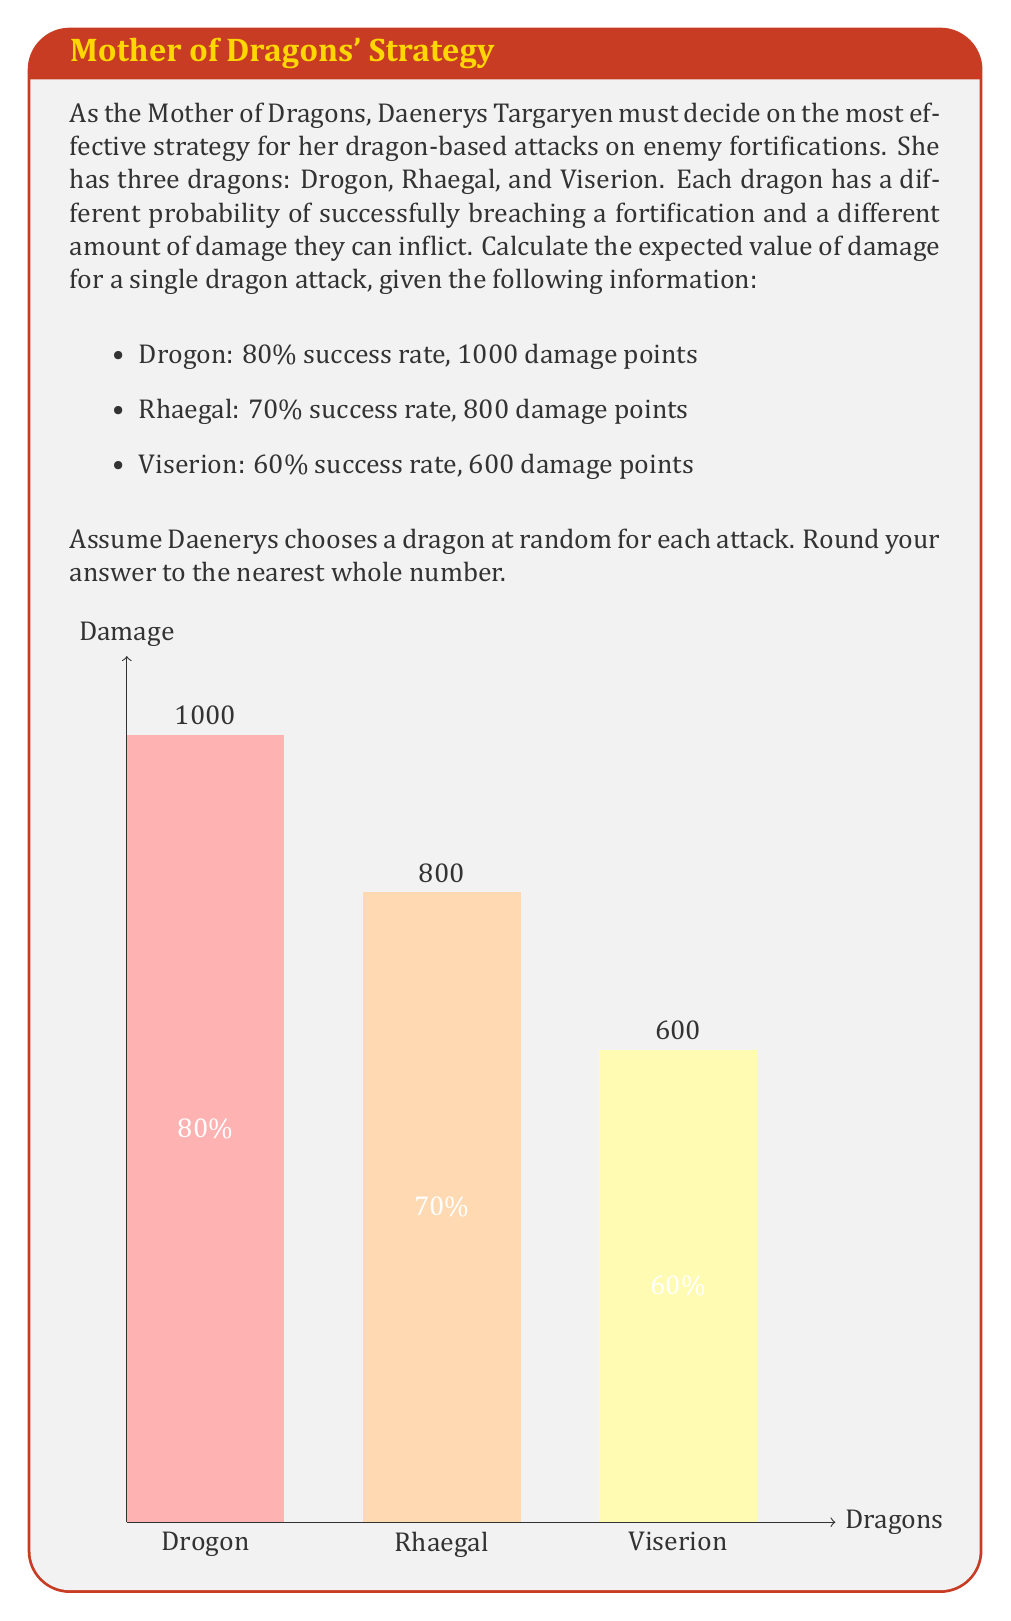Help me with this question. Let's approach this step-by-step:

1) First, we need to calculate the expected value of damage for each dragon:

   For Drogon: 
   $E(\text{Drogon}) = 0.80 \times 1000 + 0.20 \times 0 = 800$

   For Rhaegal:
   $E(\text{Rhaegal}) = 0.70 \times 800 + 0.30 \times 0 = 560$

   For Viserion:
   $E(\text{Viserion}) = 0.60 \times 600 + 0.40 \times 0 = 360$

2) Now, since Daenerys chooses a dragon at random, each dragon has an equal probability (1/3) of being chosen for an attack.

3) We can calculate the overall expected value by summing the products of each dragon's expected value and its probability of being chosen:

   $E(\text{attack}) = \frac{1}{3}E(\text{Drogon}) + \frac{1}{3}E(\text{Rhaegal}) + \frac{1}{3}E(\text{Viserion})$

4) Substituting the values:

   $E(\text{attack}) = \frac{1}{3}(800) + \frac{1}{3}(560) + \frac{1}{3}(360)$

5) Simplifying:

   $E(\text{attack}) = \frac{800 + 560 + 360}{3} = \frac{1720}{3} = 573.33$

6) Rounding to the nearest whole number:

   $E(\text{attack}) \approx 573$

Therefore, the expected value of damage for a single dragon attack, chosen at random, is approximately 573 damage points.
Answer: 573 